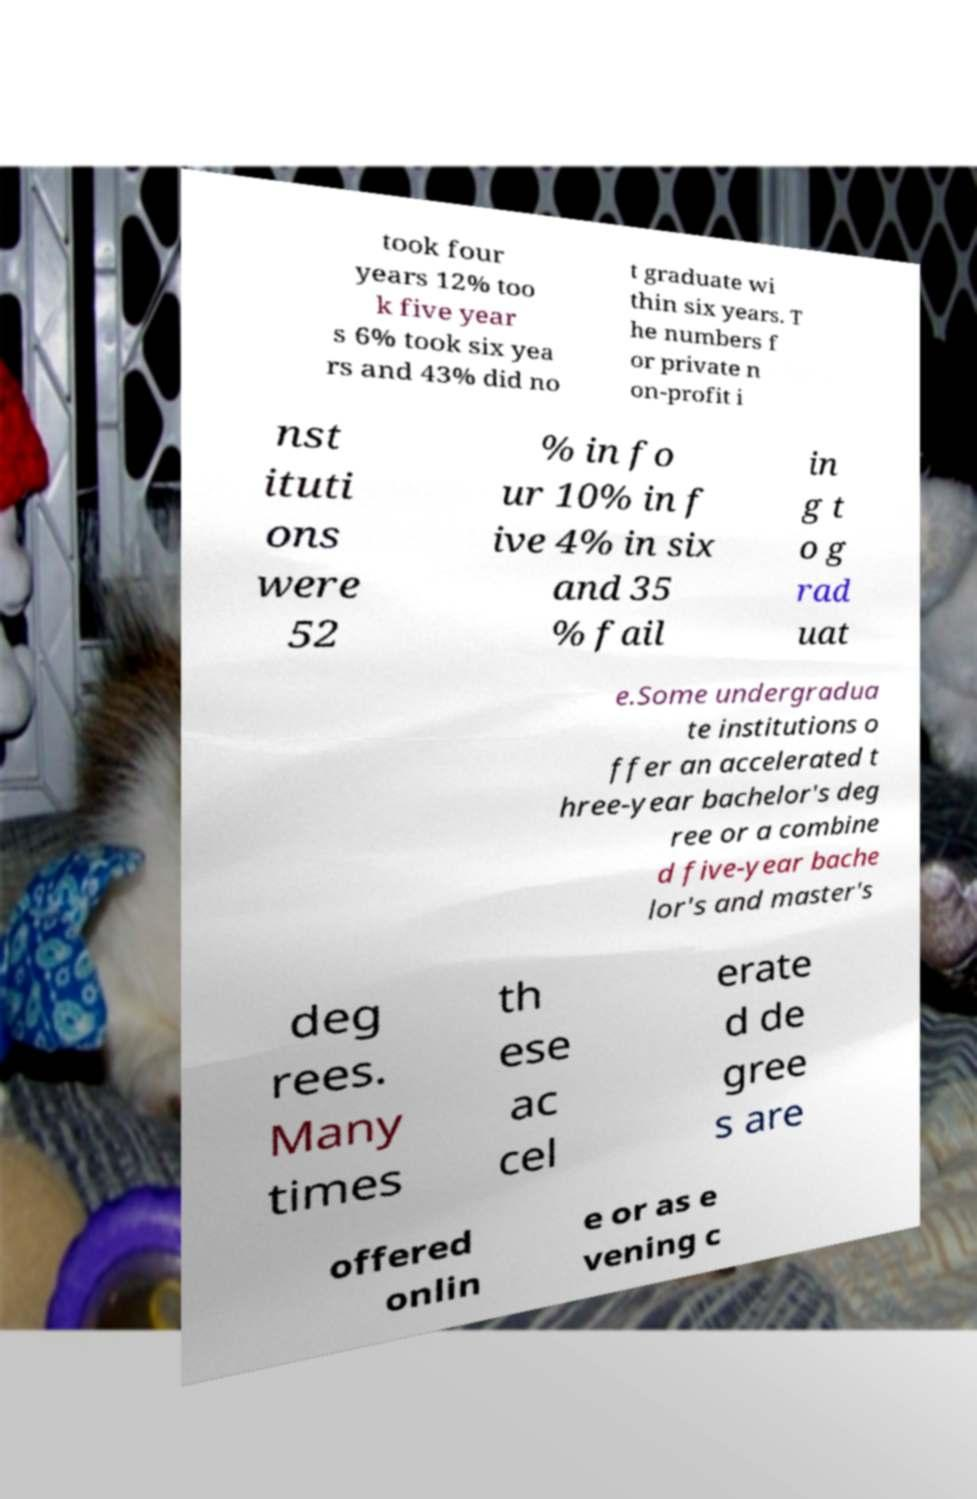Can you accurately transcribe the text from the provided image for me? took four years 12% too k five year s 6% took six yea rs and 43% did no t graduate wi thin six years. T he numbers f or private n on-profit i nst ituti ons were 52 % in fo ur 10% in f ive 4% in six and 35 % fail in g t o g rad uat e.Some undergradua te institutions o ffer an accelerated t hree-year bachelor's deg ree or a combine d five-year bache lor's and master's deg rees. Many times th ese ac cel erate d de gree s are offered onlin e or as e vening c 